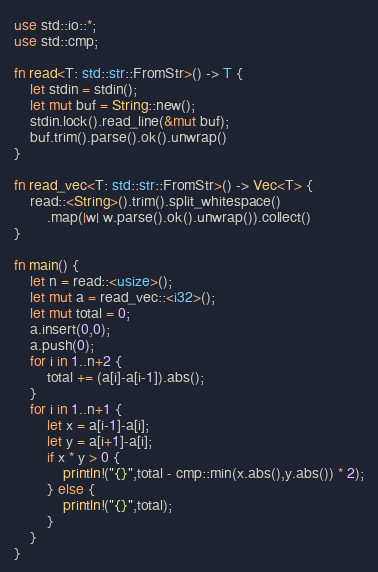Convert code to text. <code><loc_0><loc_0><loc_500><loc_500><_Rust_>use std::io::*;
use std::cmp;

fn read<T: std::str::FromStr>() -> T {
    let stdin = stdin();
    let mut buf = String::new();
	stdin.lock().read_line(&mut buf);
	buf.trim().parse().ok().unwrap()
}

fn read_vec<T: std::str::FromStr>() -> Vec<T> {
	read::<String>().trim().split_whitespace()
        .map(|w| w.parse().ok().unwrap()).collect()
}

fn main() {
    let n = read::<usize>();
    let mut a = read_vec::<i32>();
    let mut total = 0;
    a.insert(0,0);
    a.push(0);
    for i in 1..n+2 {
        total += (a[i]-a[i-1]).abs();
    }
    for i in 1..n+1 {
        let x = a[i-1]-a[i];
        let y = a[i+1]-a[i];
        if x * y > 0 {
            println!("{}",total - cmp::min(x.abs(),y.abs()) * 2);
        } else {
            println!("{}",total);
        }
    }
}
</code> 